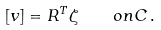Convert formula to latex. <formula><loc_0><loc_0><loc_500><loc_500>[ v ] = R ^ { T } \zeta \quad o n C \, .</formula> 